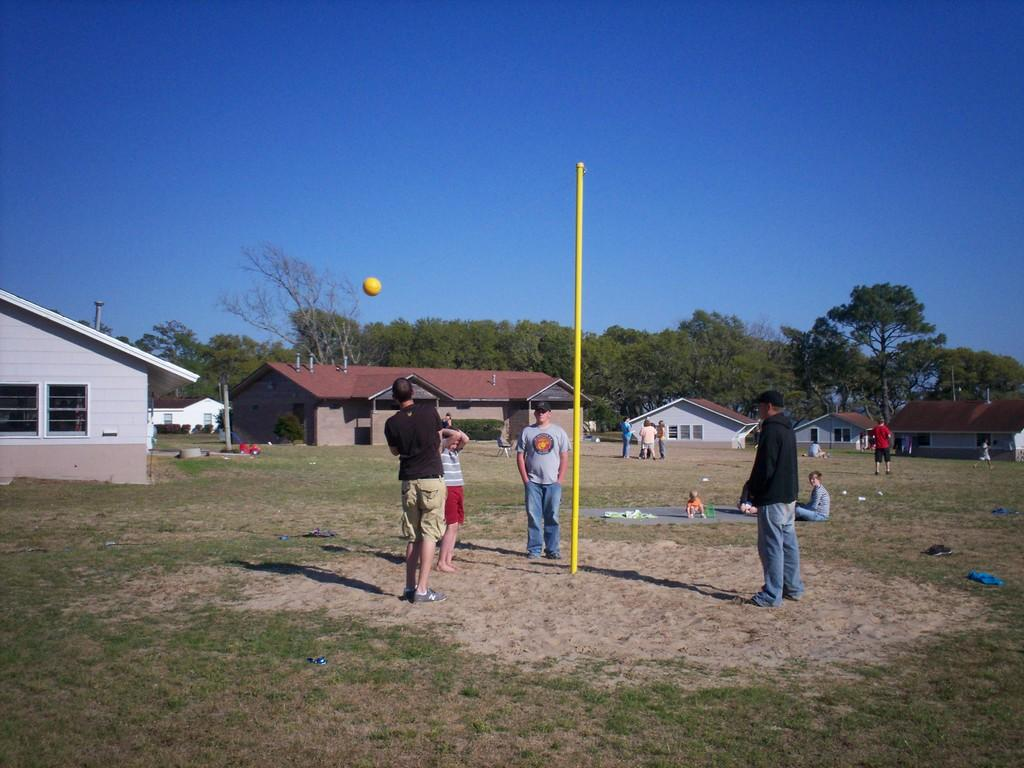Who or what can be seen in the image? There are people in the image. What type of terrain is visible in the image? There is grass in the image. What type of structures are present in the image? There are houses in the image. What is the color of the ball in the image? The ball in the image is yellow. What type of vegetation is present in the image? There are trees in the image. What part of the natural environment is visible in the image? The sky is visible in the image. What type of lock can be seen securing the bridge in the image? There is no bridge or lock present in the image. What company is responsible for maintaining the company in the image? There is no company present in the image. 